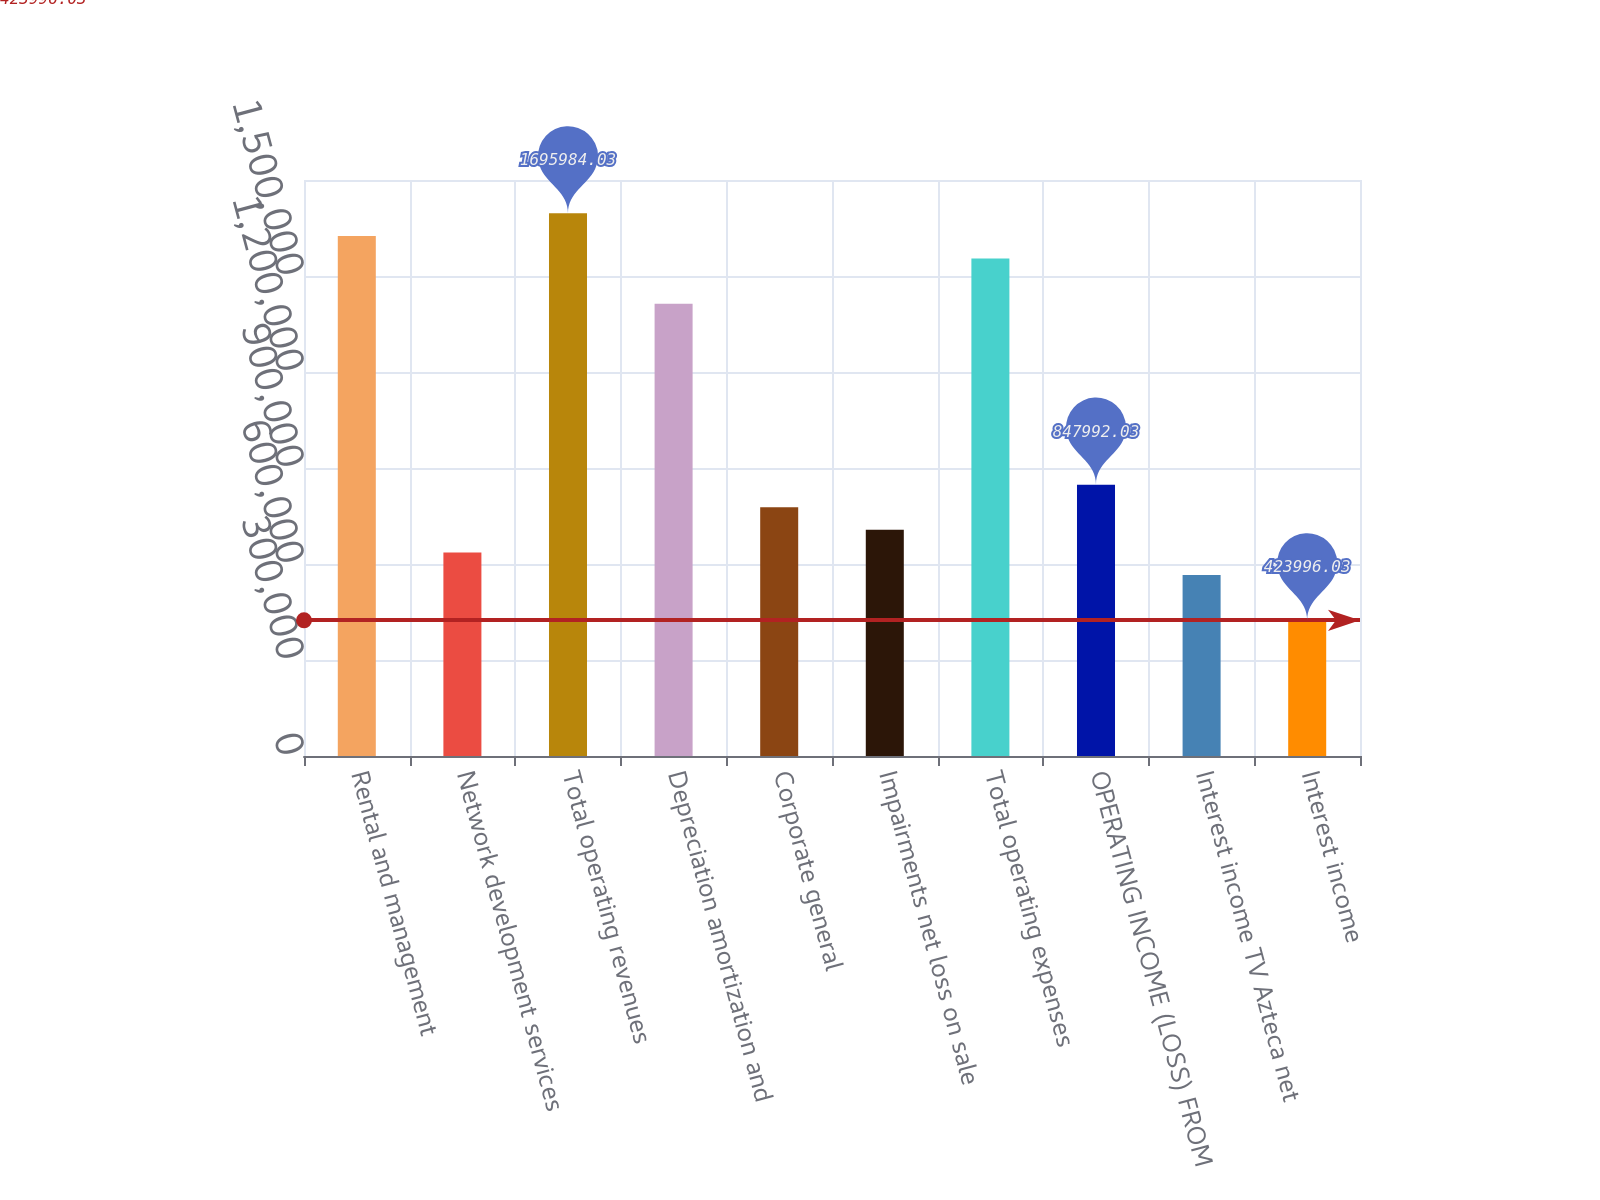<chart> <loc_0><loc_0><loc_500><loc_500><bar_chart><fcel>Rental and management<fcel>Network development services<fcel>Total operating revenues<fcel>Depreciation amortization and<fcel>Corporate general<fcel>Impairments net loss on sale<fcel>Total operating expenses<fcel>OPERATING INCOME (LOSS) FROM<fcel>Interest income TV Azteca net<fcel>Interest income<nl><fcel>1.62532e+06<fcel>635994<fcel>1.69598e+06<fcel>1.41332e+06<fcel>777326<fcel>706660<fcel>1.55465e+06<fcel>847992<fcel>565328<fcel>423996<nl></chart> 